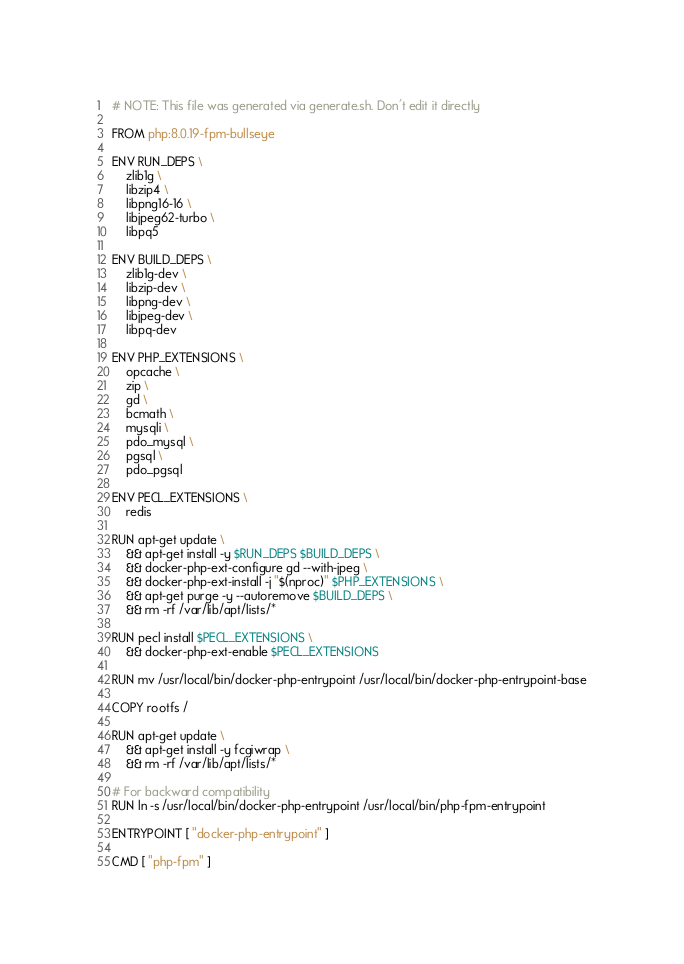Convert code to text. <code><loc_0><loc_0><loc_500><loc_500><_Dockerfile_># NOTE: This file was generated via generate.sh. Don't edit it directly

FROM php:8.0.19-fpm-bullseye

ENV RUN_DEPS \
    zlib1g \
    libzip4 \
    libpng16-16 \
    libjpeg62-turbo \
    libpq5

ENV BUILD_DEPS \
    zlib1g-dev \
    libzip-dev \
    libpng-dev \
    libjpeg-dev \
    libpq-dev

ENV PHP_EXTENSIONS \
    opcache \
    zip \
    gd \
    bcmath \
    mysqli \
    pdo_mysql \
    pgsql \
    pdo_pgsql

ENV PECL_EXTENSIONS \
    redis

RUN apt-get update \
    && apt-get install -y $RUN_DEPS $BUILD_DEPS \
    && docker-php-ext-configure gd --with-jpeg \
    && docker-php-ext-install -j "$(nproc)" $PHP_EXTENSIONS \
    && apt-get purge -y --autoremove $BUILD_DEPS \
    && rm -rf /var/lib/apt/lists/*

RUN pecl install $PECL_EXTENSIONS \
    && docker-php-ext-enable $PECL_EXTENSIONS

RUN mv /usr/local/bin/docker-php-entrypoint /usr/local/bin/docker-php-entrypoint-base

COPY rootfs /

RUN apt-get update \
    && apt-get install -y fcgiwrap \
    && rm -rf /var/lib/apt/lists/*

# For backward compatibility
RUN ln -s /usr/local/bin/docker-php-entrypoint /usr/local/bin/php-fpm-entrypoint

ENTRYPOINT [ "docker-php-entrypoint" ]

CMD [ "php-fpm" ]
</code> 